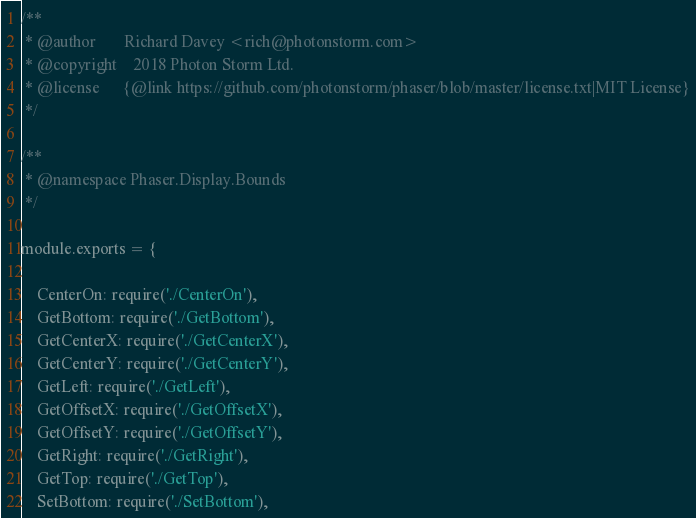<code> <loc_0><loc_0><loc_500><loc_500><_JavaScript_>/**
 * @author       Richard Davey <rich@photonstorm.com>
 * @copyright    2018 Photon Storm Ltd.
 * @license      {@link https://github.com/photonstorm/phaser/blob/master/license.txt|MIT License}
 */

/**
 * @namespace Phaser.Display.Bounds
 */

module.exports = {

    CenterOn: require('./CenterOn'),
    GetBottom: require('./GetBottom'),
    GetCenterX: require('./GetCenterX'),
    GetCenterY: require('./GetCenterY'),
    GetLeft: require('./GetLeft'),
    GetOffsetX: require('./GetOffsetX'),
    GetOffsetY: require('./GetOffsetY'),
    GetRight: require('./GetRight'),
    GetTop: require('./GetTop'),
    SetBottom: require('./SetBottom'),</code> 